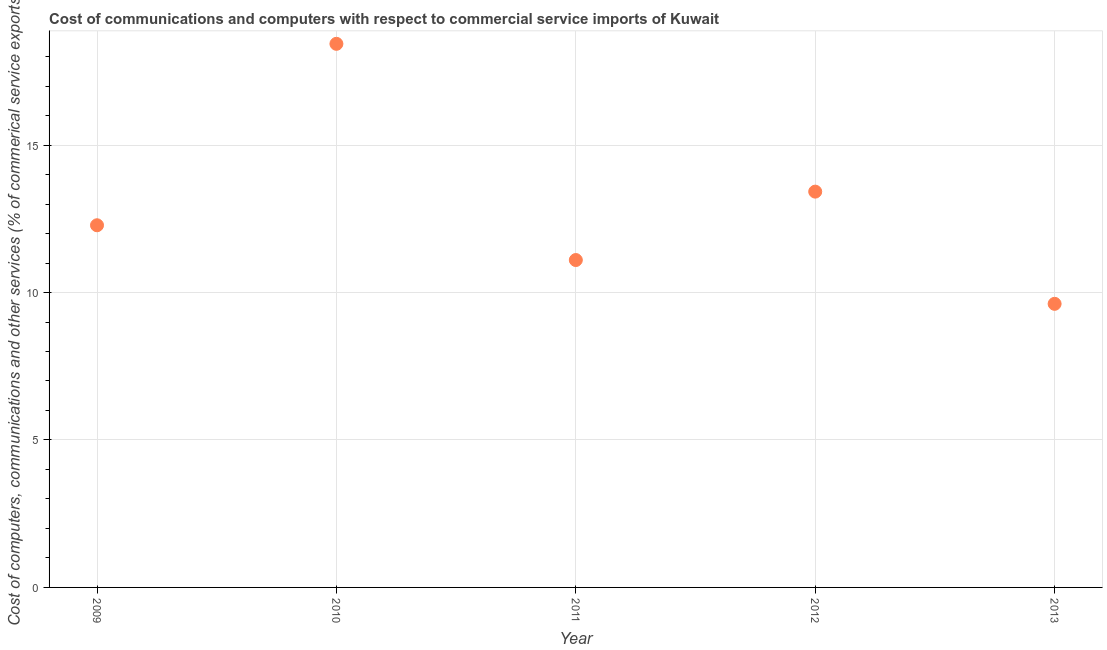What is the  computer and other services in 2010?
Provide a short and direct response. 18.43. Across all years, what is the maximum cost of communications?
Keep it short and to the point. 18.43. Across all years, what is the minimum cost of communications?
Your answer should be compact. 9.62. What is the sum of the cost of communications?
Offer a terse response. 64.85. What is the difference between the cost of communications in 2011 and 2013?
Offer a terse response. 1.48. What is the average cost of communications per year?
Keep it short and to the point. 12.97. What is the median  computer and other services?
Ensure brevity in your answer.  12.28. In how many years, is the cost of communications greater than 13 %?
Give a very brief answer. 2. Do a majority of the years between 2012 and 2013 (inclusive) have cost of communications greater than 16 %?
Provide a succinct answer. No. What is the ratio of the cost of communications in 2009 to that in 2010?
Your answer should be very brief. 0.67. Is the difference between the cost of communications in 2011 and 2012 greater than the difference between any two years?
Make the answer very short. No. What is the difference between the highest and the second highest cost of communications?
Make the answer very short. 5.01. Is the sum of the  computer and other services in 2009 and 2012 greater than the maximum  computer and other services across all years?
Your response must be concise. Yes. What is the difference between the highest and the lowest cost of communications?
Your answer should be compact. 8.82. In how many years, is the  computer and other services greater than the average  computer and other services taken over all years?
Make the answer very short. 2. What is the difference between two consecutive major ticks on the Y-axis?
Keep it short and to the point. 5. What is the title of the graph?
Make the answer very short. Cost of communications and computers with respect to commercial service imports of Kuwait. What is the label or title of the X-axis?
Offer a terse response. Year. What is the label or title of the Y-axis?
Provide a short and direct response. Cost of computers, communications and other services (% of commerical service exports). What is the Cost of computers, communications and other services (% of commerical service exports) in 2009?
Make the answer very short. 12.28. What is the Cost of computers, communications and other services (% of commerical service exports) in 2010?
Provide a succinct answer. 18.43. What is the Cost of computers, communications and other services (% of commerical service exports) in 2011?
Provide a short and direct response. 11.1. What is the Cost of computers, communications and other services (% of commerical service exports) in 2012?
Make the answer very short. 13.42. What is the Cost of computers, communications and other services (% of commerical service exports) in 2013?
Provide a short and direct response. 9.62. What is the difference between the Cost of computers, communications and other services (% of commerical service exports) in 2009 and 2010?
Your answer should be very brief. -6.15. What is the difference between the Cost of computers, communications and other services (% of commerical service exports) in 2009 and 2011?
Provide a succinct answer. 1.18. What is the difference between the Cost of computers, communications and other services (% of commerical service exports) in 2009 and 2012?
Provide a short and direct response. -1.14. What is the difference between the Cost of computers, communications and other services (% of commerical service exports) in 2009 and 2013?
Make the answer very short. 2.66. What is the difference between the Cost of computers, communications and other services (% of commerical service exports) in 2010 and 2011?
Ensure brevity in your answer.  7.33. What is the difference between the Cost of computers, communications and other services (% of commerical service exports) in 2010 and 2012?
Keep it short and to the point. 5.01. What is the difference between the Cost of computers, communications and other services (% of commerical service exports) in 2010 and 2013?
Provide a short and direct response. 8.82. What is the difference between the Cost of computers, communications and other services (% of commerical service exports) in 2011 and 2012?
Offer a very short reply. -2.32. What is the difference between the Cost of computers, communications and other services (% of commerical service exports) in 2011 and 2013?
Your answer should be very brief. 1.48. What is the difference between the Cost of computers, communications and other services (% of commerical service exports) in 2012 and 2013?
Give a very brief answer. 3.8. What is the ratio of the Cost of computers, communications and other services (% of commerical service exports) in 2009 to that in 2010?
Provide a succinct answer. 0.67. What is the ratio of the Cost of computers, communications and other services (% of commerical service exports) in 2009 to that in 2011?
Your answer should be very brief. 1.11. What is the ratio of the Cost of computers, communications and other services (% of commerical service exports) in 2009 to that in 2012?
Provide a short and direct response. 0.92. What is the ratio of the Cost of computers, communications and other services (% of commerical service exports) in 2009 to that in 2013?
Keep it short and to the point. 1.28. What is the ratio of the Cost of computers, communications and other services (% of commerical service exports) in 2010 to that in 2011?
Offer a very short reply. 1.66. What is the ratio of the Cost of computers, communications and other services (% of commerical service exports) in 2010 to that in 2012?
Make the answer very short. 1.37. What is the ratio of the Cost of computers, communications and other services (% of commerical service exports) in 2010 to that in 2013?
Provide a short and direct response. 1.92. What is the ratio of the Cost of computers, communications and other services (% of commerical service exports) in 2011 to that in 2012?
Give a very brief answer. 0.83. What is the ratio of the Cost of computers, communications and other services (% of commerical service exports) in 2011 to that in 2013?
Provide a short and direct response. 1.15. What is the ratio of the Cost of computers, communications and other services (% of commerical service exports) in 2012 to that in 2013?
Your answer should be very brief. 1.4. 